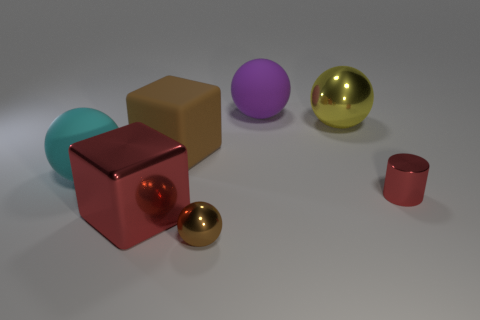Subtract 1 balls. How many balls are left? 3 Add 1 yellow metal objects. How many objects exist? 8 Subtract all balls. How many objects are left? 3 Add 4 shiny spheres. How many shiny spheres exist? 6 Subtract 0 blue spheres. How many objects are left? 7 Subtract all small cyan matte balls. Subtract all big metal balls. How many objects are left? 6 Add 6 red metallic cubes. How many red metallic cubes are left? 7 